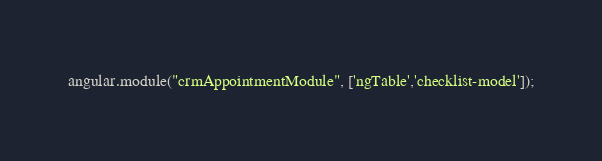<code> <loc_0><loc_0><loc_500><loc_500><_JavaScript_>angular.module("crmAppointmentModule", ['ngTable','checklist-model']);</code> 